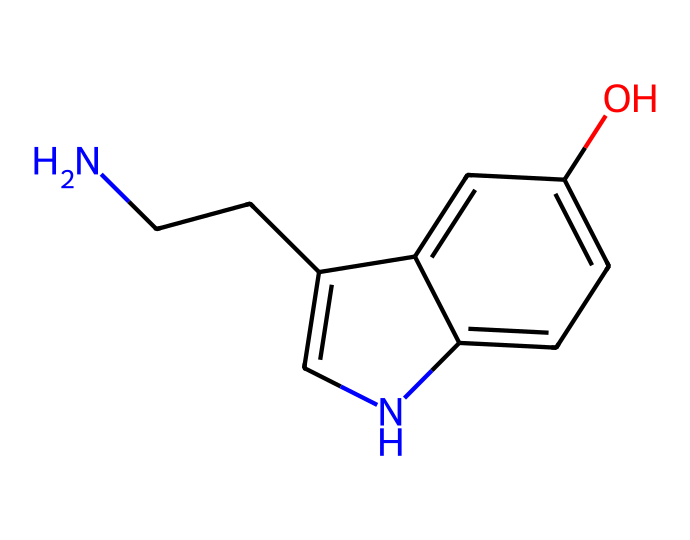How many carbon atoms are in this molecule? By analyzing the molecular structure derived from the SMILES representation, we identify individual carbon (C) atoms mentioned in the structure. There are multiple segments, and upon counting, we can identify that there are 10 carbon atoms in total.
Answer: 10 What functional group is present in this molecule? Looking closely at the SMILES representation, the segment represented by "O" indicates the presence of a hydroxyl group (-OH), which is characteristic of alcohols. Thus, this molecule has an alcohol functional group.
Answer: alcohol Are there any nitrogen atoms in this structure? The SMILES string features the "N" character, indicating the presence of nitrogen atoms. By reviewing the structure, we find that there is indeed one nitrogen atom present in the molecule.
Answer: 1 What is the molecular weight of this compound? To estimate the molecular weight, we analyze the number of each type of atom present and their respective atomic weights (C=12, H=1, N=14, O=16). Calculating the total gives us a molecular weight of 174.23 g/mol.
Answer: 174.23 g/mol Which part of the molecule indicates its polarity? In this molecule, the presence of the hydroxyl group (-OH) suggests a polar environment due to the oxygen atom, which can engage in hydrogen bonding. This indicates that the molecule as a whole may exhibit polar characteristics.
Answer: hydroxyl group What type of bonding is likely present in this chemical based on its structure? Analyzing the SMILES notation, we see both single and aromatic bonds among the carbon and nitrogen atoms, specifically the ring structure, which indicates the presence of resonance and delocalized electrons typical of aromatic compounds.
Answer: aromatic bonding 